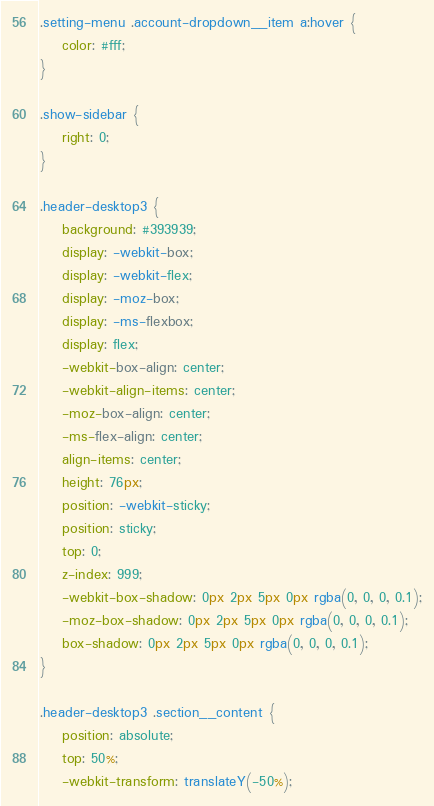<code> <loc_0><loc_0><loc_500><loc_500><_CSS_>
.setting-menu .account-dropdown__item a:hover {
    color: #fff;
}

.show-sidebar {
    right: 0;
}

.header-desktop3 {
    background: #393939;
    display: -webkit-box;
    display: -webkit-flex;
    display: -moz-box;
    display: -ms-flexbox;
    display: flex;
    -webkit-box-align: center;
    -webkit-align-items: center;
    -moz-box-align: center;
    -ms-flex-align: center;
    align-items: center;
    height: 76px;
    position: -webkit-sticky;
    position: sticky;
    top: 0;
    z-index: 999;
    -webkit-box-shadow: 0px 2px 5px 0px rgba(0, 0, 0, 0.1);
    -moz-box-shadow: 0px 2px 5px 0px rgba(0, 0, 0, 0.1);
    box-shadow: 0px 2px 5px 0px rgba(0, 0, 0, 0.1);
}

.header-desktop3 .section__content {
    position: absolute;
    top: 50%;
    -webkit-transform: translateY(-50%);</code> 